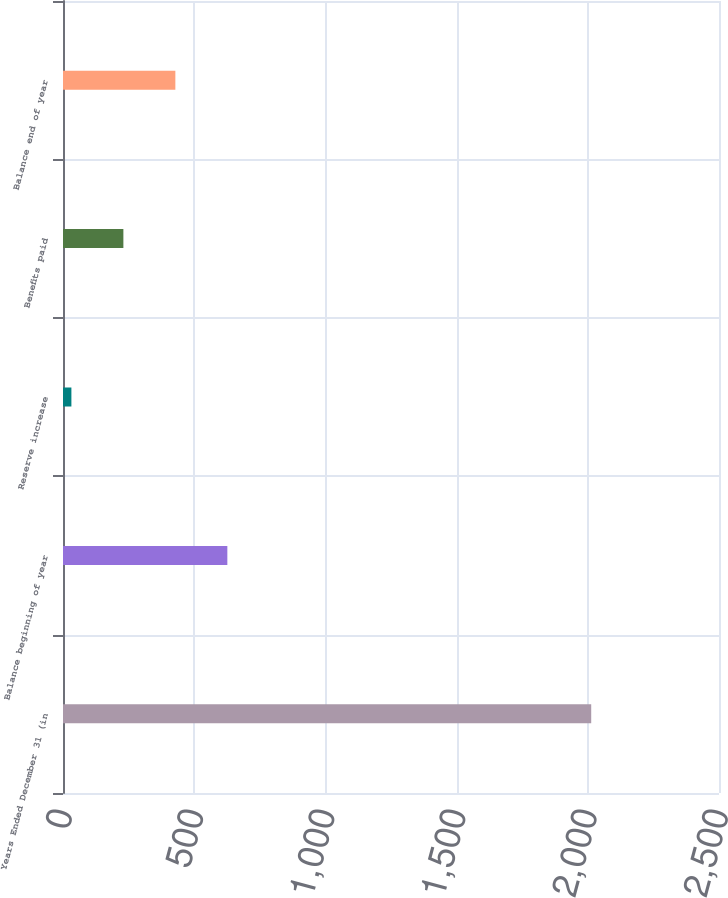Convert chart. <chart><loc_0><loc_0><loc_500><loc_500><bar_chart><fcel>Years Ended December 31 (in<fcel>Balance beginning of year<fcel>Reserve increase<fcel>Benefits paid<fcel>Balance end of year<nl><fcel>2013<fcel>626.3<fcel>32<fcel>230.1<fcel>428.2<nl></chart> 